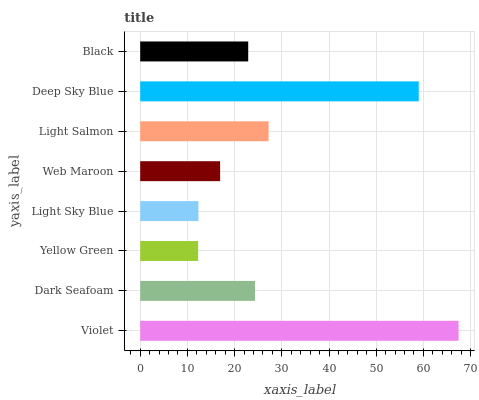Is Yellow Green the minimum?
Answer yes or no. Yes. Is Violet the maximum?
Answer yes or no. Yes. Is Dark Seafoam the minimum?
Answer yes or no. No. Is Dark Seafoam the maximum?
Answer yes or no. No. Is Violet greater than Dark Seafoam?
Answer yes or no. Yes. Is Dark Seafoam less than Violet?
Answer yes or no. Yes. Is Dark Seafoam greater than Violet?
Answer yes or no. No. Is Violet less than Dark Seafoam?
Answer yes or no. No. Is Dark Seafoam the high median?
Answer yes or no. Yes. Is Black the low median?
Answer yes or no. Yes. Is Violet the high median?
Answer yes or no. No. Is Light Salmon the low median?
Answer yes or no. No. 